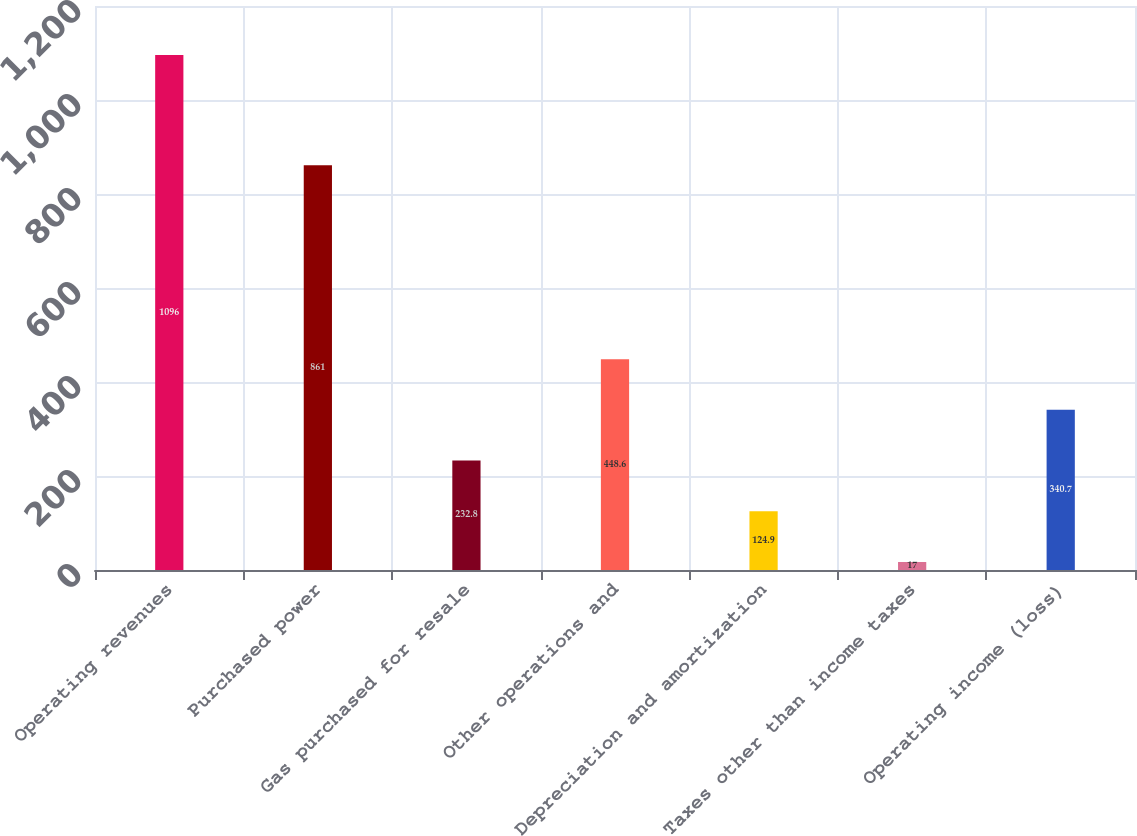Convert chart to OTSL. <chart><loc_0><loc_0><loc_500><loc_500><bar_chart><fcel>Operating revenues<fcel>Purchased power<fcel>Gas purchased for resale<fcel>Other operations and<fcel>Depreciation and amortization<fcel>Taxes other than income taxes<fcel>Operating income (loss)<nl><fcel>1096<fcel>861<fcel>232.8<fcel>448.6<fcel>124.9<fcel>17<fcel>340.7<nl></chart> 